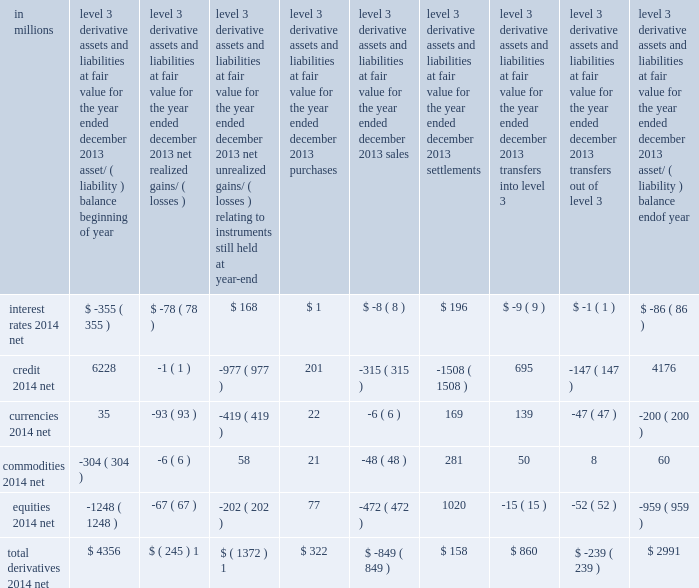Notes to consolidated financial statements level 3 rollforward if a derivative was transferred to level 3 during a reporting period , its entire gain or loss for the period is included in level 3 .
Transfers between levels are reported at the beginning of the reporting period in which they occur .
In the tables below , negative amounts for transfers into level 3 and positive amounts for transfers out of level 3 represent net transfers of derivative liabilities .
Gains and losses on level 3 derivatives should be considered in the context of the following : 2030 a derivative with level 1 and/or level 2 inputs is classified in level 3 in its entirety if it has at least one significant level 3 input .
2030 if there is one significant level 3 input , the entire gain or loss from adjusting only observable inputs ( i.e. , level 1 and level 2 inputs ) is classified as level 3 .
2030 gains or losses that have been reported in level 3 resulting from changes in level 1 or level 2 inputs are frequently offset by gains or losses attributable to level 1 or level 2 derivatives and/or level 1 , level 2 and level 3 cash instruments .
As a result , gains/ ( losses ) included in the level 3 rollforward below do not necessarily represent the overall impact on the firm 2019s results of operations , liquidity or capital resources .
The tables below present changes in fair value for all derivatives categorized as level 3 as of the end of the year. .
The aggregate amounts include losses of approximately $ 1.29 billion and $ 324 million reported in 201cmarket making 201d and 201cother principal transactions , 201d respectively .
The net unrealized loss on level 3 derivatives of $ 1.37 billion for 2013 principally resulted from changes in level 2 inputs and was primarily attributable to losses on certain credit derivatives , principally due to the impact of tighter credit spreads , and losses on certain currency derivatives , primarily due to changes in foreign exchange rates .
Transfers into level 3 derivatives during 2013 primarily reflected transfers of credit derivative assets from level 2 , principally due to reduced transparency of upfront credit points and correlation inputs used to value these derivatives .
Transfers out of level 3 derivatives during 2013 primarily reflected transfers of certain credit derivatives to level 2 , principally due to unobservable credit spread and correlation inputs no longer being significant to the valuation of these derivatives and unobservable inputs not being significant to the net risk of certain portfolios .
Goldman sachs 2013 annual report 143 .
What was the total derivatives-net change for level 3 derivative assets and liabilities at fair value for the year from the beginning of 2013 to the end of 2013 , in millions? 
Computations: (2991 - 4356)
Answer: -1365.0. 